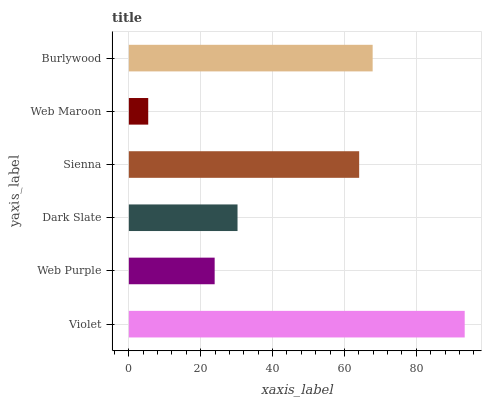Is Web Maroon the minimum?
Answer yes or no. Yes. Is Violet the maximum?
Answer yes or no. Yes. Is Web Purple the minimum?
Answer yes or no. No. Is Web Purple the maximum?
Answer yes or no. No. Is Violet greater than Web Purple?
Answer yes or no. Yes. Is Web Purple less than Violet?
Answer yes or no. Yes. Is Web Purple greater than Violet?
Answer yes or no. No. Is Violet less than Web Purple?
Answer yes or no. No. Is Sienna the high median?
Answer yes or no. Yes. Is Dark Slate the low median?
Answer yes or no. Yes. Is Dark Slate the high median?
Answer yes or no. No. Is Web Purple the low median?
Answer yes or no. No. 